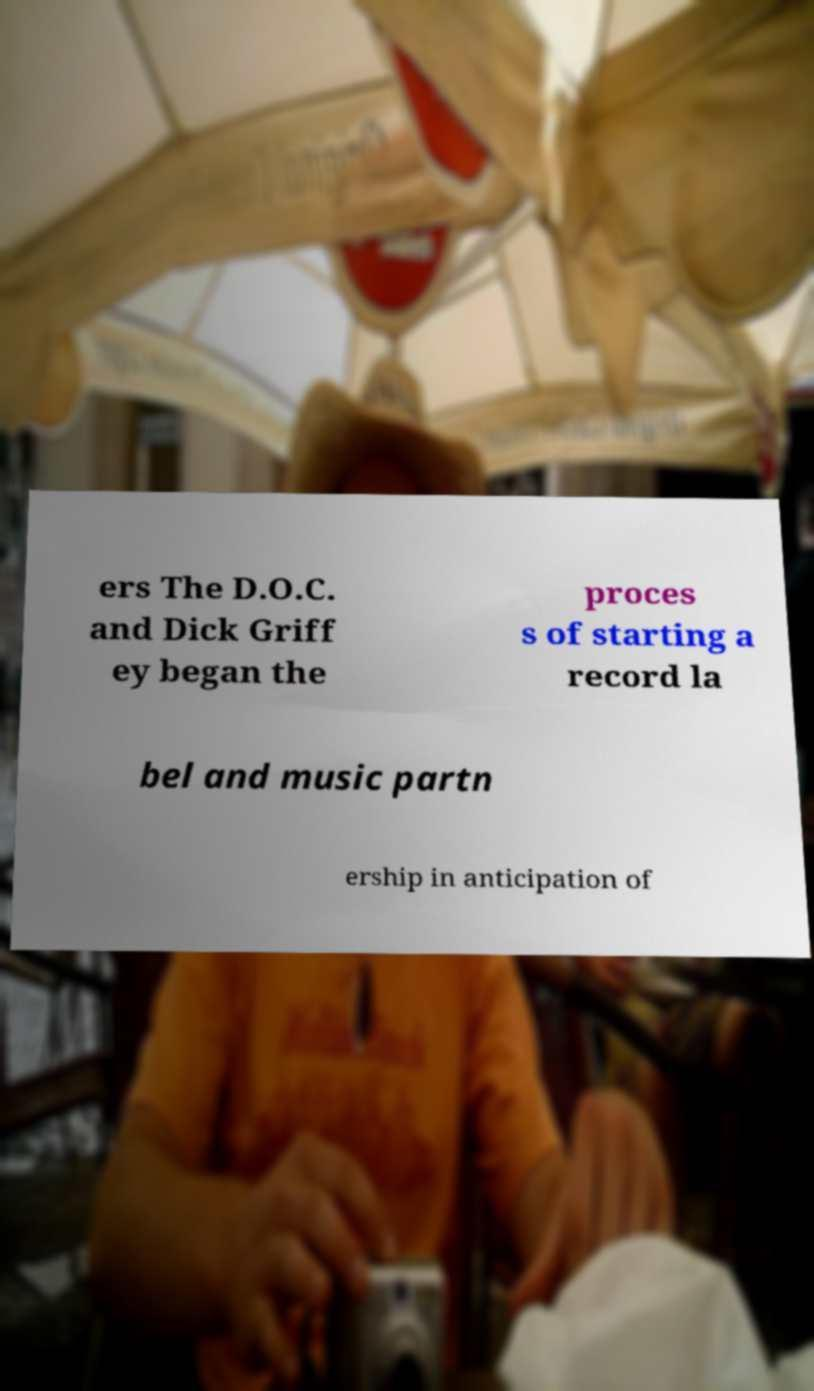Please read and relay the text visible in this image. What does it say? ers The D.O.C. and Dick Griff ey began the proces s of starting a record la bel and music partn ership in anticipation of 